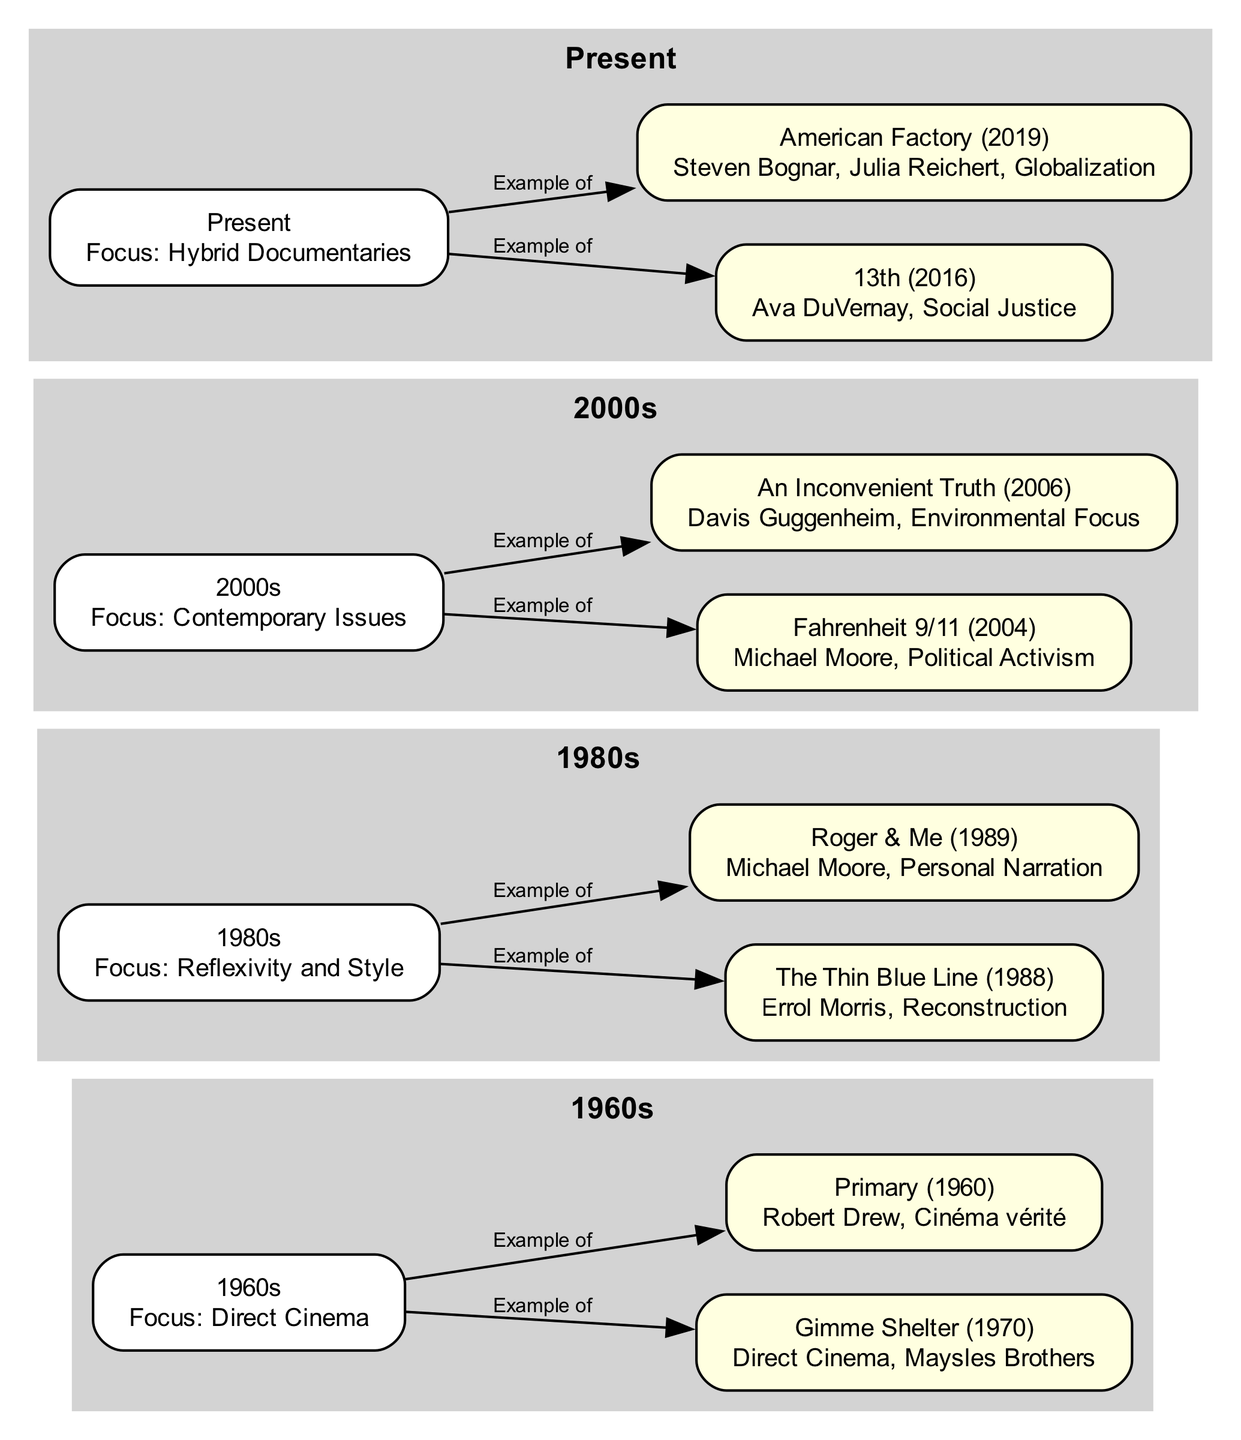What documentary is associated with the 1960s? The document shows that "Gimme Shelter" and "Primary" are both linked to the 1960s in the diagram. Since the question asks for any documentary from that era, we can mention either of them, but we'll choose one for simplicity.
Answer: Gimme Shelter How many documentaries are represented in the 1980s? There are two example documentaries listed under the 1980s: "The Thin Blue Line" and "Roger & Me." Thus, the total count of documentaries for that period is 2.
Answer: 2 Which documentary focuses on political activism? From the diagram, "Fahrenheit 9/11" is explicitly described as focusing on "Political Activism." Therefore, this title is the clear answer to the question.
Answer: Fahrenheit 9/11 What type of documentary focuses on social justice in the present? The diagram indicates that "13th," created by Ava DuVernay, is the documentary associated with social justice in the present section. This leads us directly to the answer.
Answer: 13th How many edges are connected to the 2000s node? Examining the edges coming from the 2000s node, there are two connections: one to "Fahrenheit 9/11" and another to "An Inconvenient Truth." Therefore, the total is 2 edges connected to that node.
Answer: 2 What is the focus of documentaries in the Present? The diagram specifies that the focus of documentaries in the Present is "Hybrid Documentaries." This succinctly answers the question.
Answer: Hybrid Documentaries Which documentary from the 1980s used personal narration? The diagram specifies that "Roger & Me" is the documentary from the 1980s that employs personal narration as its style. Thus, our answer is straightforward.
Answer: Roger & Me What visual influence is seen in the 2000s documentaries? The provided diagram states that the 2000s documentaries focus on "Contemporary Issues," illuminating the visual influence that emerged during that era.
Answer: Contemporary Issues 